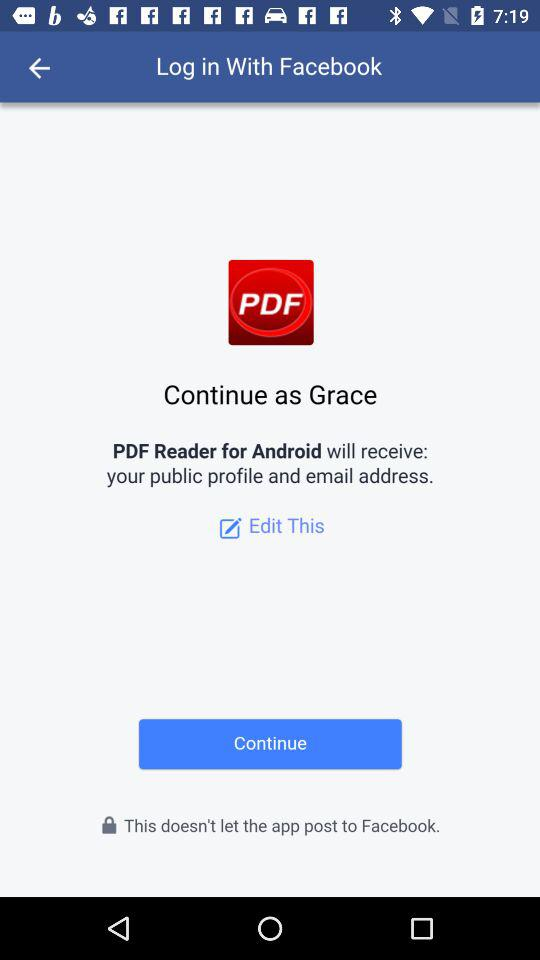Who will receive my public profile and email address? The application that will receive your public profile and email address is "PDF Reader for Android". 